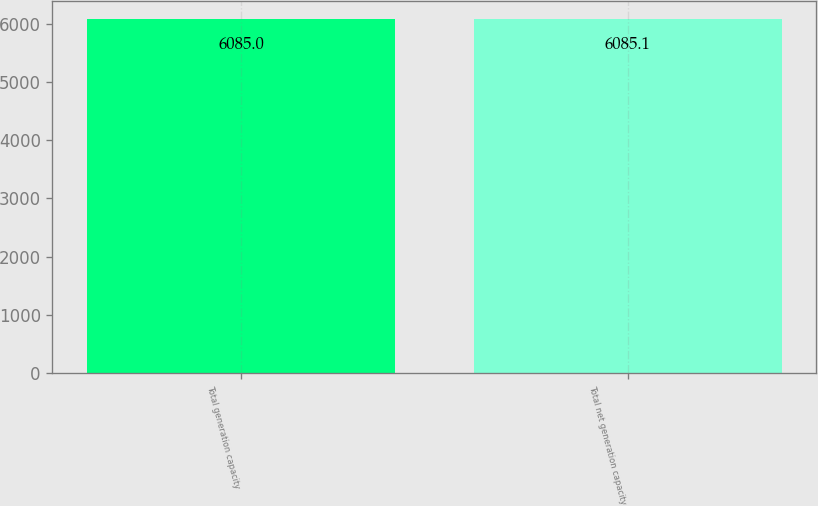<chart> <loc_0><loc_0><loc_500><loc_500><bar_chart><fcel>Total generation capacity<fcel>Total net generation capacity<nl><fcel>6085<fcel>6085.1<nl></chart> 